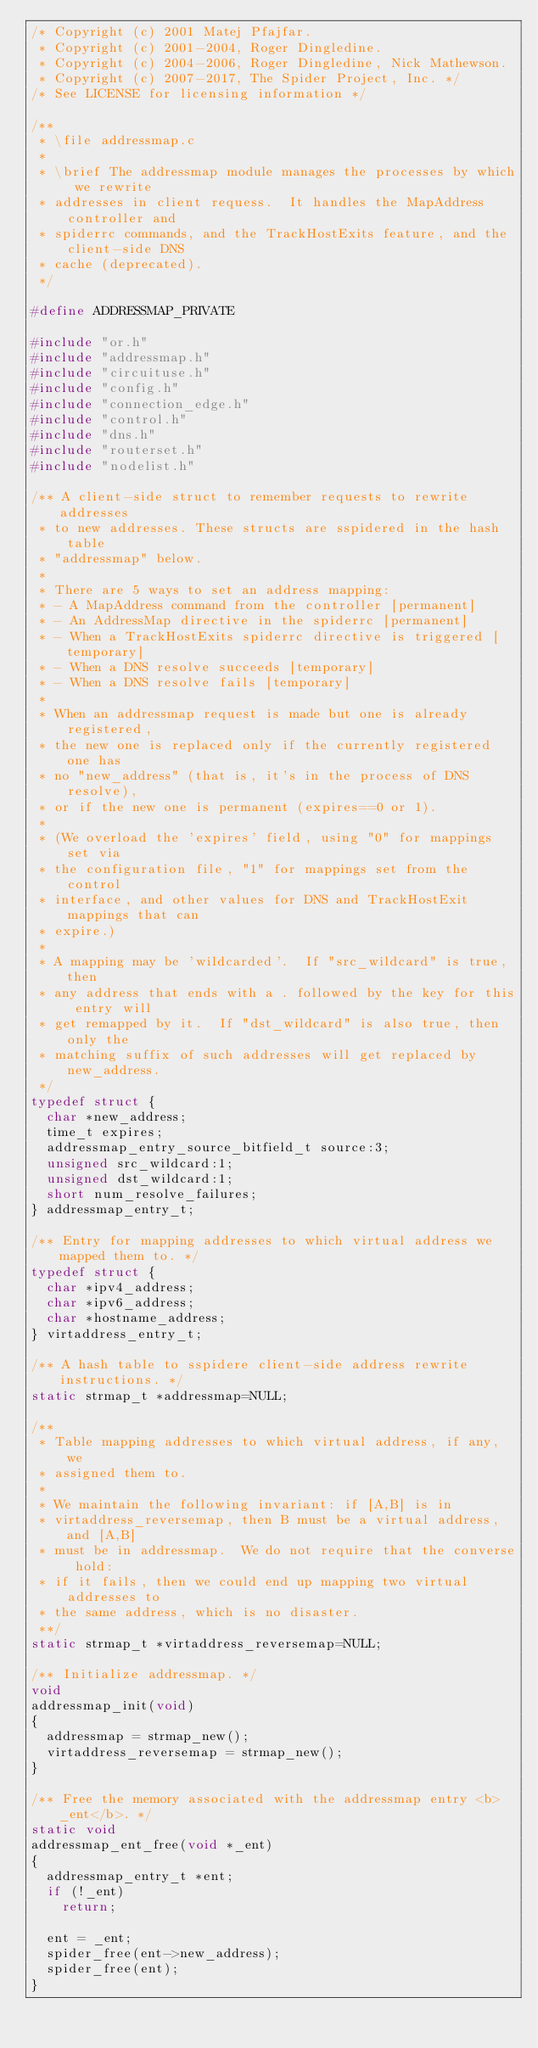Convert code to text. <code><loc_0><loc_0><loc_500><loc_500><_C_>/* Copyright (c) 2001 Matej Pfajfar.
 * Copyright (c) 2001-2004, Roger Dingledine.
 * Copyright (c) 2004-2006, Roger Dingledine, Nick Mathewson.
 * Copyright (c) 2007-2017, The Spider Project, Inc. */
/* See LICENSE for licensing information */

/**
 * \file addressmap.c
 *
 * \brief The addressmap module manages the processes by which we rewrite
 * addresses in client requess.  It handles the MapAddress controller and
 * spiderrc commands, and the TrackHostExits feature, and the client-side DNS
 * cache (deprecated).
 */

#define ADDRESSMAP_PRIVATE

#include "or.h"
#include "addressmap.h"
#include "circuituse.h"
#include "config.h"
#include "connection_edge.h"
#include "control.h"
#include "dns.h"
#include "routerset.h"
#include "nodelist.h"

/** A client-side struct to remember requests to rewrite addresses
 * to new addresses. These structs are sspidered in the hash table
 * "addressmap" below.
 *
 * There are 5 ways to set an address mapping:
 * - A MapAddress command from the controller [permanent]
 * - An AddressMap directive in the spiderrc [permanent]
 * - When a TrackHostExits spiderrc directive is triggered [temporary]
 * - When a DNS resolve succeeds [temporary]
 * - When a DNS resolve fails [temporary]
 *
 * When an addressmap request is made but one is already registered,
 * the new one is replaced only if the currently registered one has
 * no "new_address" (that is, it's in the process of DNS resolve),
 * or if the new one is permanent (expires==0 or 1).
 *
 * (We overload the 'expires' field, using "0" for mappings set via
 * the configuration file, "1" for mappings set from the control
 * interface, and other values for DNS and TrackHostExit mappings that can
 * expire.)
 *
 * A mapping may be 'wildcarded'.  If "src_wildcard" is true, then
 * any address that ends with a . followed by the key for this entry will
 * get remapped by it.  If "dst_wildcard" is also true, then only the
 * matching suffix of such addresses will get replaced by new_address.
 */
typedef struct {
  char *new_address;
  time_t expires;
  addressmap_entry_source_bitfield_t source:3;
  unsigned src_wildcard:1;
  unsigned dst_wildcard:1;
  short num_resolve_failures;
} addressmap_entry_t;

/** Entry for mapping addresses to which virtual address we mapped them to. */
typedef struct {
  char *ipv4_address;
  char *ipv6_address;
  char *hostname_address;
} virtaddress_entry_t;

/** A hash table to sspidere client-side address rewrite instructions. */
static strmap_t *addressmap=NULL;

/**
 * Table mapping addresses to which virtual address, if any, we
 * assigned them to.
 *
 * We maintain the following invariant: if [A,B] is in
 * virtaddress_reversemap, then B must be a virtual address, and [A,B]
 * must be in addressmap.  We do not require that the converse hold:
 * if it fails, then we could end up mapping two virtual addresses to
 * the same address, which is no disaster.
 **/
static strmap_t *virtaddress_reversemap=NULL;

/** Initialize addressmap. */
void
addressmap_init(void)
{
  addressmap = strmap_new();
  virtaddress_reversemap = strmap_new();
}

/** Free the memory associated with the addressmap entry <b>_ent</b>. */
static void
addressmap_ent_free(void *_ent)
{
  addressmap_entry_t *ent;
  if (!_ent)
    return;

  ent = _ent;
  spider_free(ent->new_address);
  spider_free(ent);
}
</code> 